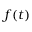Convert formula to latex. <formula><loc_0><loc_0><loc_500><loc_500>f ( t )</formula> 